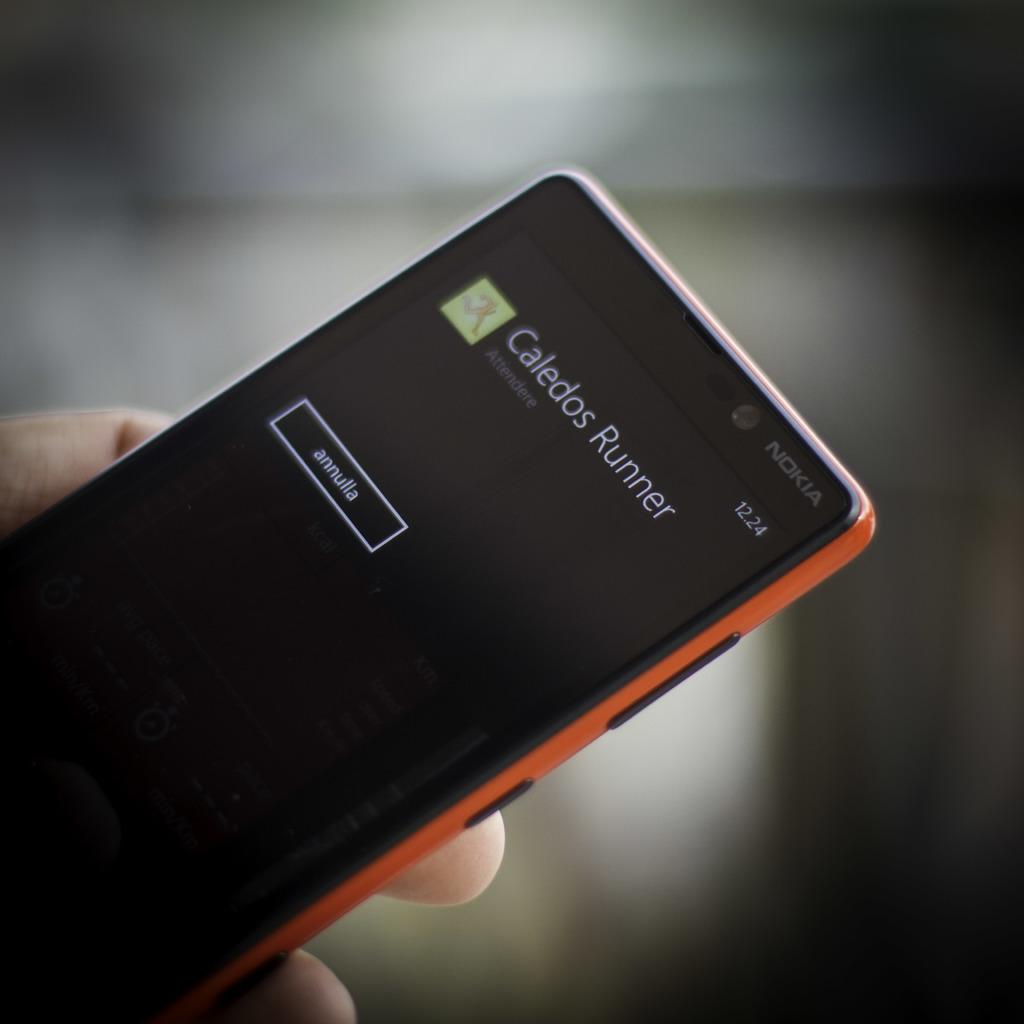<image>
Write a terse but informative summary of the picture. A person holding a Nokia with Caledos Runner displayed on the screen. 